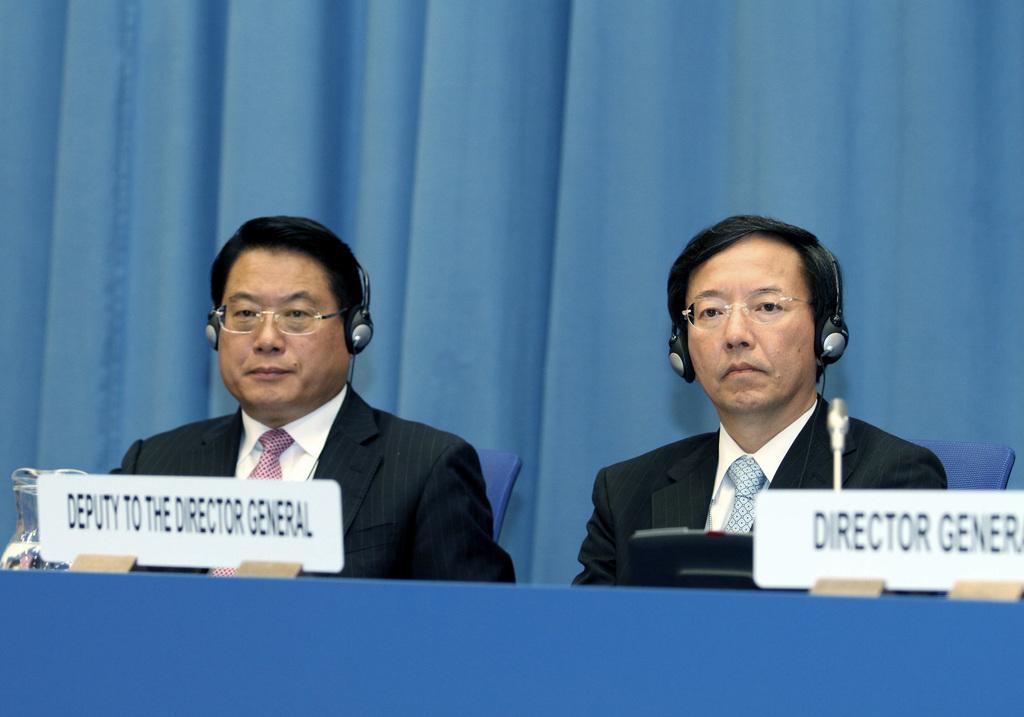Who is he deputy to?
Your answer should be compact. Director general. 